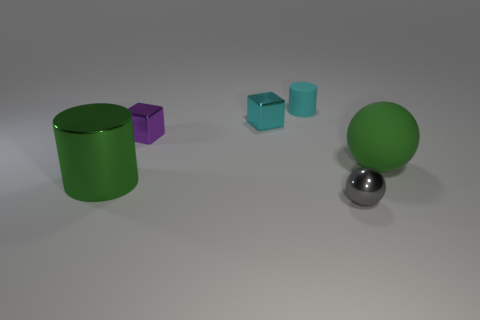There is a object that is the same color as the big matte ball; what material is it?
Your answer should be very brief. Metal. Do the gray metallic sphere and the rubber thing that is on the right side of the metal sphere have the same size?
Offer a very short reply. No. Are there any matte spheres of the same color as the large metal object?
Offer a terse response. Yes. Are there any shiny objects of the same shape as the tiny cyan matte thing?
Offer a terse response. Yes. The shiny thing that is both in front of the large green sphere and to the right of the large shiny thing has what shape?
Provide a short and direct response. Sphere. How many small spheres are made of the same material as the cyan block?
Offer a very short reply. 1. Are there fewer cyan metal cubes in front of the tiny sphere than tiny red metallic balls?
Your response must be concise. No. Is there a shiny ball in front of the large thing that is left of the purple metal object?
Provide a short and direct response. Yes. Do the cyan rubber object and the purple block have the same size?
Make the answer very short. Yes. The cylinder that is behind the big green object that is right of the tiny thing in front of the large green matte sphere is made of what material?
Your response must be concise. Rubber. 